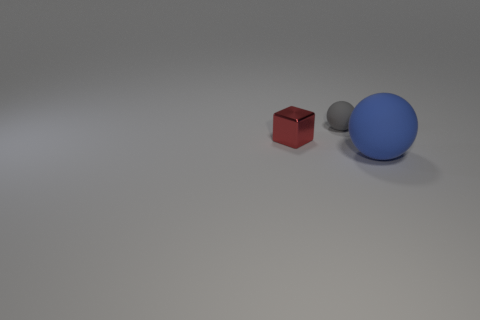What time of day does the lighting in the scene suggest? The soft shadows and neutral lighting suggest an overcast day, or an indoor setting with diffused artificial lighting, as there's no clear indication of direct sunlight or strong light sources. 